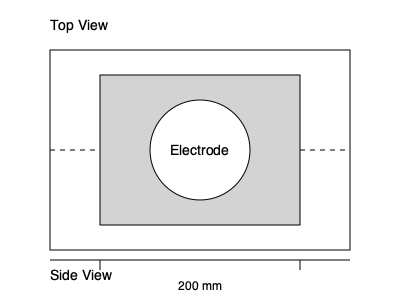Based on the 3D technical drawing of a battery component shown above, what is the diameter of the circular electrode in millimeters? To determine the diameter of the circular electrode, we need to follow these steps:

1. Identify the scale: The drawing shows a top view and a side view of the battery component. The side view indicates that the total width of the rectangular component is 200 mm.

2. Compare the rectangular component's width to the drawing: In the top view, the rectangular component spans from x-coordinate 100 to 300, which is 200 units in the drawing.

3. Establish the scale ratio: 200 mm in reality corresponds to 200 units in the drawing, so the scale is 1:1 (1 mm = 1 unit in the drawing).

4. Measure the electrode: The circular electrode is centered within the rectangular component. Its diameter spans 100 units in the drawing (from x-coordinate 150 to 250).

5. Convert to real dimensions: Since the scale is 1:1, 100 units in the drawing equals 100 mm in reality.

Therefore, the diameter of the circular electrode is 100 mm.
Answer: 100 mm 